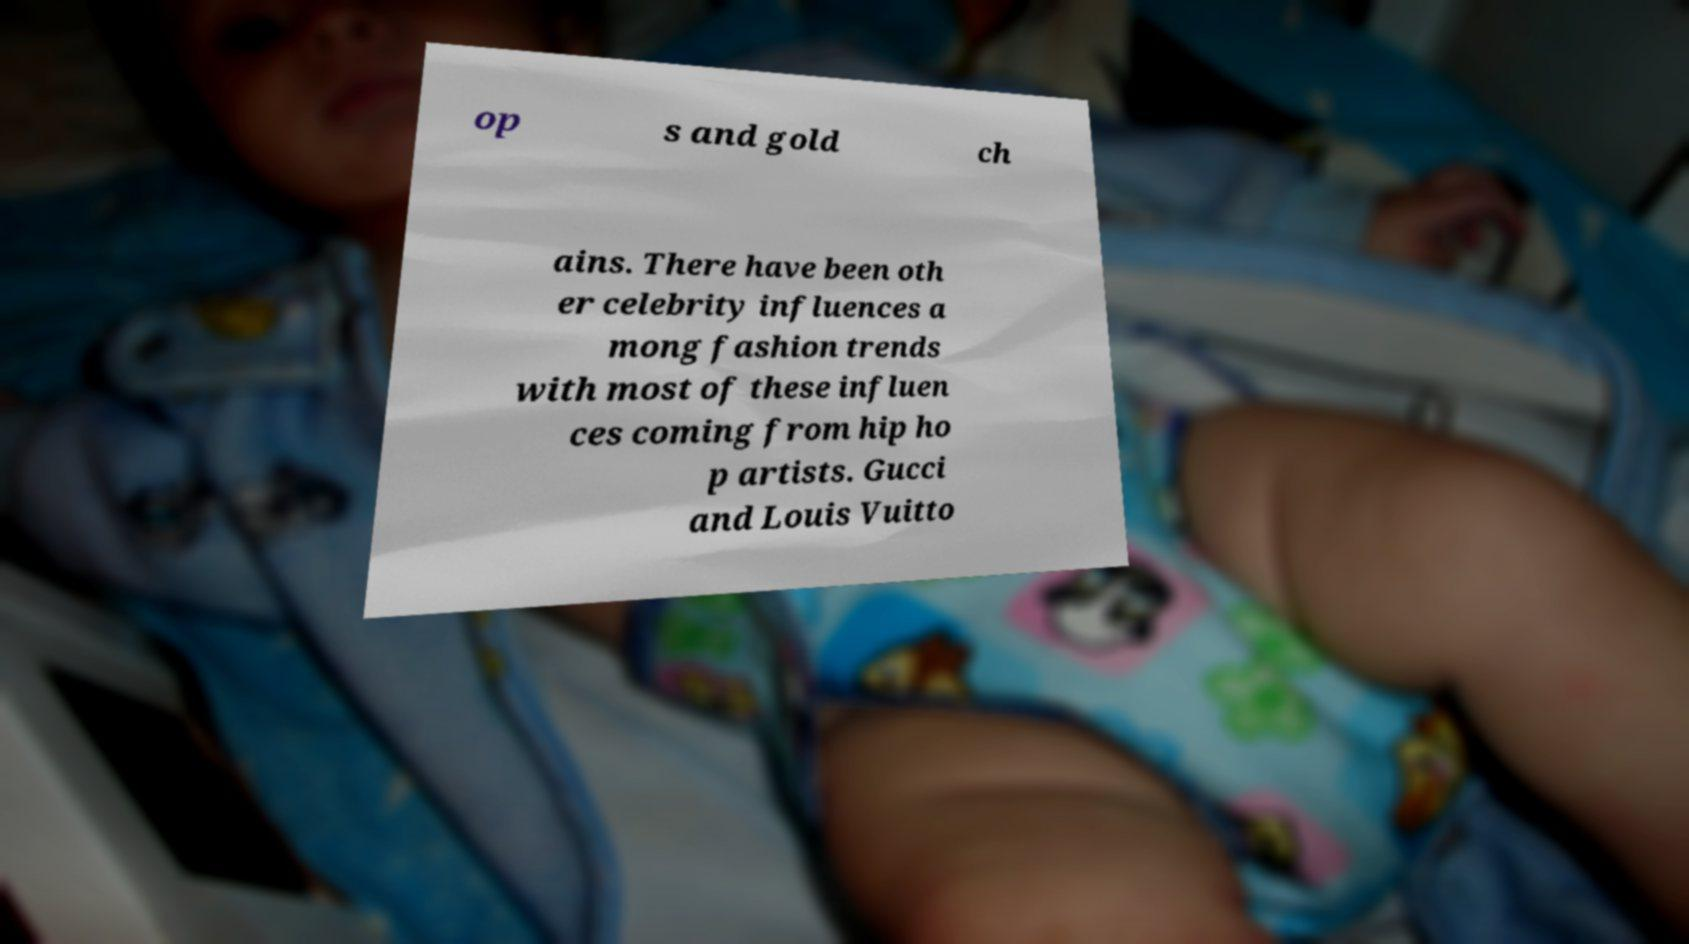What messages or text are displayed in this image? I need them in a readable, typed format. op s and gold ch ains. There have been oth er celebrity influences a mong fashion trends with most of these influen ces coming from hip ho p artists. Gucci and Louis Vuitto 